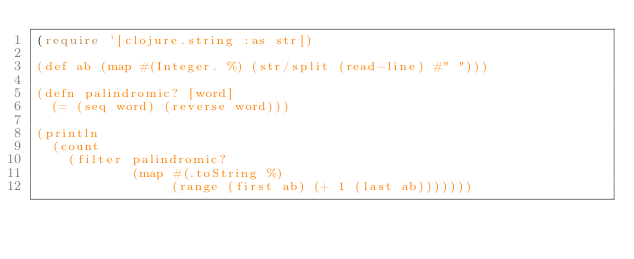Convert code to text. <code><loc_0><loc_0><loc_500><loc_500><_Clojure_>(require '[clojure.string :as str])

(def ab (map #(Integer. %) (str/split (read-line) #" ")))

(defn palindromic? [word]
  (= (seq word) (reverse word)))

(println 
  (count 
    (filter palindromic? 
            (map #(.toString %) 
                 (range (first ab) (+ 1 (last ab)))))))
</code> 